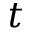<formula> <loc_0><loc_0><loc_500><loc_500>t</formula> 